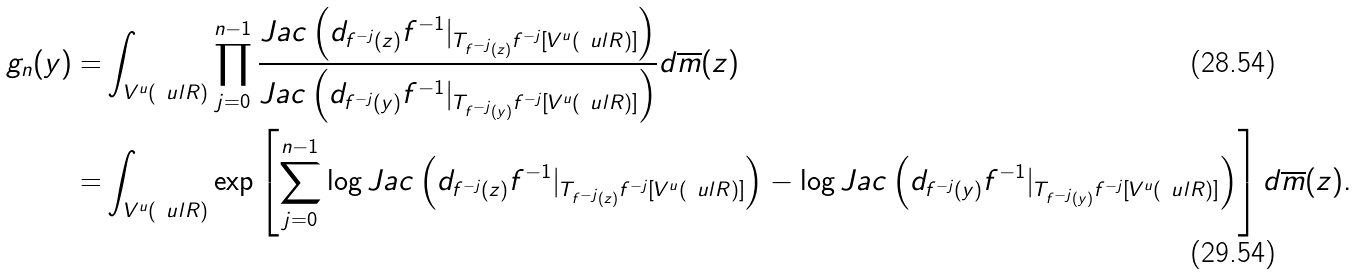<formula> <loc_0><loc_0><loc_500><loc_500>g _ { n } ( y ) = & \int _ { V ^ { u } ( \ u l { R } ) } \prod _ { j = 0 } ^ { n - 1 } \frac { J a c \left ( d _ { f ^ { - j } ( z ) } f ^ { - 1 } | _ { T _ { f ^ { - j } ( z ) } f ^ { - j } [ V ^ { u } ( \ u l { R } ) ] } \right ) } { J a c \left ( d _ { f ^ { - j } ( y ) } f ^ { - 1 } | _ { T _ { f ^ { - j } ( y ) } f ^ { - j } [ V ^ { u } ( \ u l { R } ) ] } \right ) } d \overline { m } ( z ) \\ = & \int _ { V ^ { u } ( \ u l { R } ) } \exp \left [ \sum _ { j = 0 } ^ { n - 1 } \log J a c \left ( d _ { f ^ { - j } ( z ) } f ^ { - 1 } | _ { T _ { f ^ { - j } ( z ) } f ^ { - j } [ V ^ { u } ( \ u l { R } ) ] } \right ) - \log J a c \left ( d _ { f ^ { - j } ( y ) } f ^ { - 1 } | _ { T _ { f ^ { - j } ( y ) } f ^ { - j } [ V ^ { u } ( \ u l { R } ) ] } \right ) \right ] d \overline { m } ( z ) .</formula> 